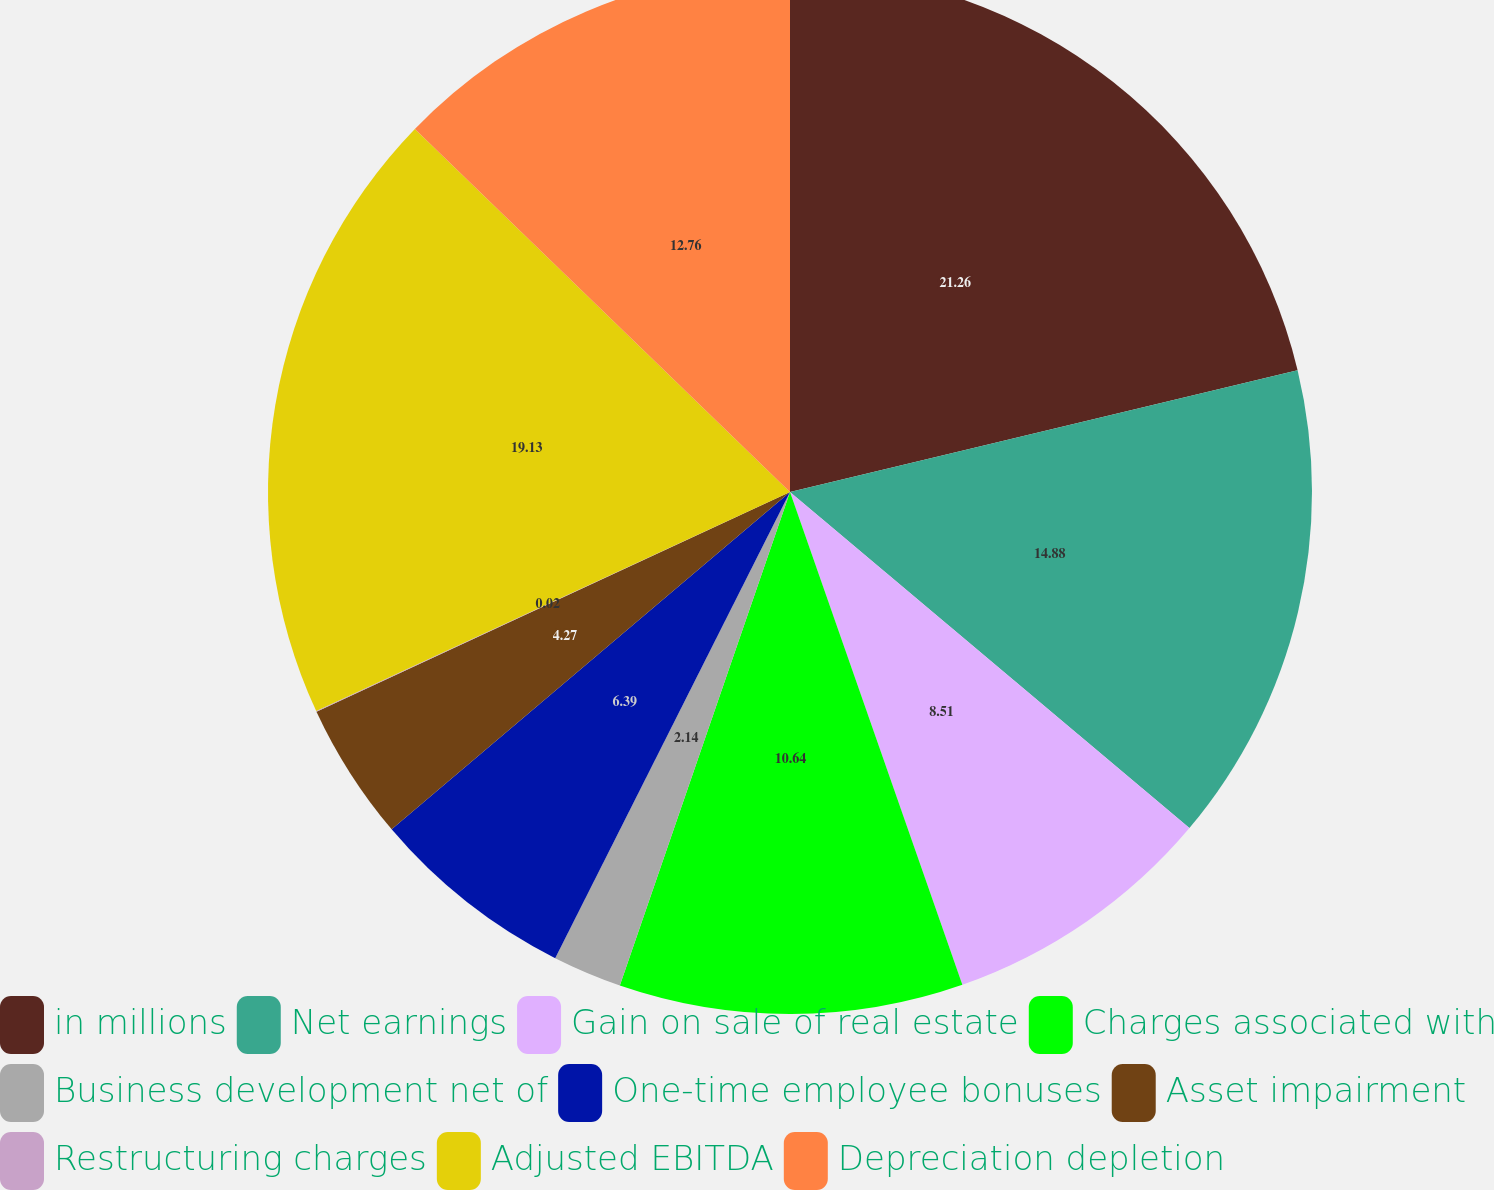<chart> <loc_0><loc_0><loc_500><loc_500><pie_chart><fcel>in millions<fcel>Net earnings<fcel>Gain on sale of real estate<fcel>Charges associated with<fcel>Business development net of<fcel>One-time employee bonuses<fcel>Asset impairment<fcel>Restructuring charges<fcel>Adjusted EBITDA<fcel>Depreciation depletion<nl><fcel>21.25%<fcel>14.88%<fcel>8.51%<fcel>10.64%<fcel>2.14%<fcel>6.39%<fcel>4.27%<fcel>0.02%<fcel>19.13%<fcel>12.76%<nl></chart> 